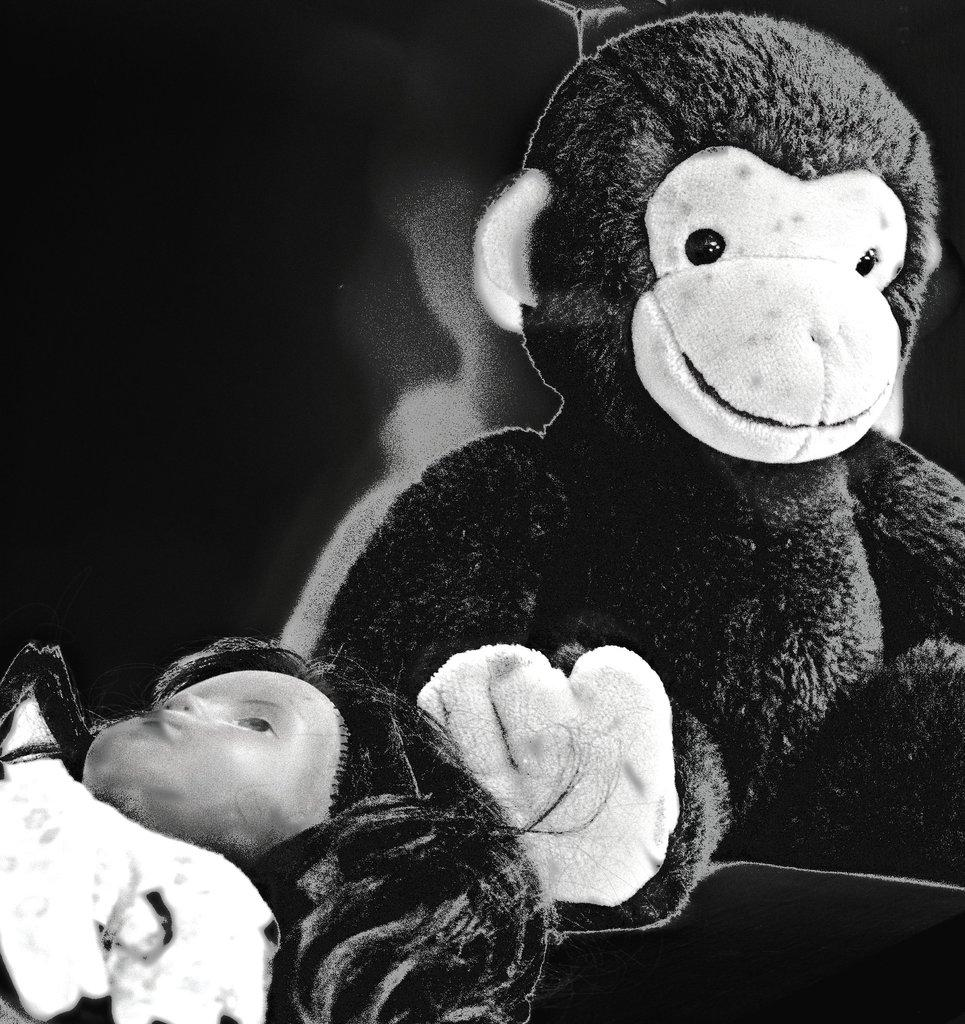What type of objects are present in the image? There are dolls in the image. Can you describe the background of the image? The background of the image is blurred. What type of plantation can be seen in the background of the image? There is no plantation present in the image; the background is blurred. Is there a cemetery visible in the image? There is no cemetery present in the image; the background is blurred. 